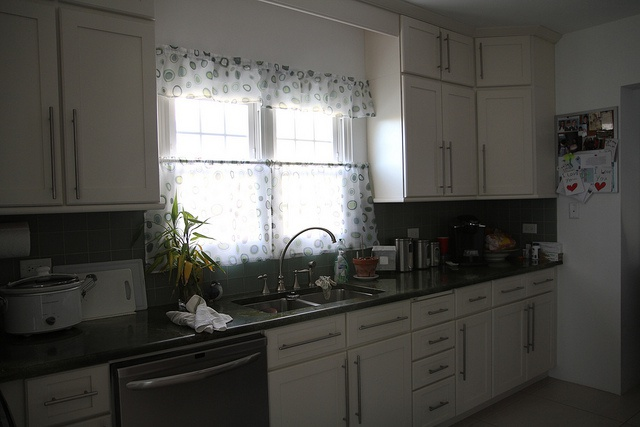Describe the objects in this image and their specific colors. I can see oven in black and gray tones, potted plant in black, white, gray, and darkgreen tones, bowl in black and gray tones, sink in black, gray, and darkgray tones, and bowl in black tones in this image. 